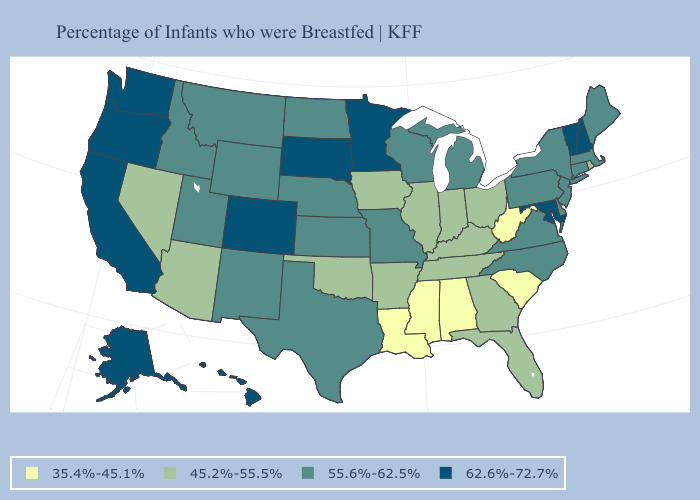What is the lowest value in the USA?
Keep it brief. 35.4%-45.1%. What is the lowest value in states that border South Carolina?
Keep it brief. 45.2%-55.5%. What is the lowest value in states that border Texas?
Answer briefly. 35.4%-45.1%. What is the highest value in states that border North Carolina?
Keep it brief. 55.6%-62.5%. What is the value of Texas?
Be succinct. 55.6%-62.5%. Name the states that have a value in the range 55.6%-62.5%?
Answer briefly. Connecticut, Delaware, Idaho, Kansas, Maine, Massachusetts, Michigan, Missouri, Montana, Nebraska, New Jersey, New Mexico, New York, North Carolina, North Dakota, Pennsylvania, Texas, Utah, Virginia, Wisconsin, Wyoming. Which states have the highest value in the USA?
Keep it brief. Alaska, California, Colorado, Hawaii, Maryland, Minnesota, New Hampshire, Oregon, South Dakota, Vermont, Washington. Among the states that border South Carolina , does North Carolina have the highest value?
Answer briefly. Yes. Name the states that have a value in the range 45.2%-55.5%?
Keep it brief. Arizona, Arkansas, Florida, Georgia, Illinois, Indiana, Iowa, Kentucky, Nevada, Ohio, Oklahoma, Rhode Island, Tennessee. Does Florida have a lower value than Rhode Island?
Write a very short answer. No. What is the value of North Carolina?
Quick response, please. 55.6%-62.5%. What is the highest value in states that border Wisconsin?
Keep it brief. 62.6%-72.7%. What is the value of Wisconsin?
Be succinct. 55.6%-62.5%. What is the value of Florida?
Answer briefly. 45.2%-55.5%. Does the map have missing data?
Concise answer only. No. 